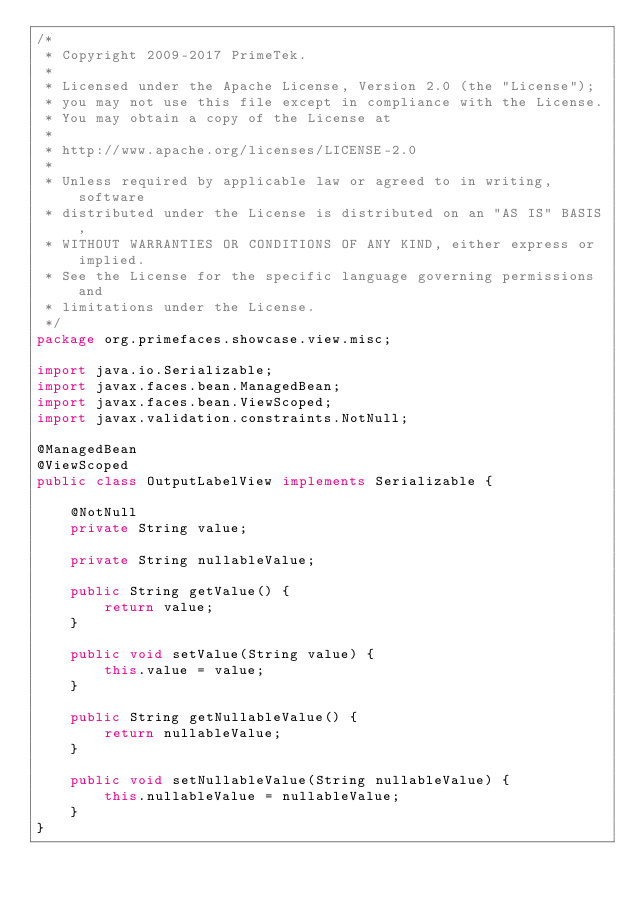<code> <loc_0><loc_0><loc_500><loc_500><_Java_>/*
 * Copyright 2009-2017 PrimeTek.
 *
 * Licensed under the Apache License, Version 2.0 (the "License");
 * you may not use this file except in compliance with the License.
 * You may obtain a copy of the License at
 *
 * http://www.apache.org/licenses/LICENSE-2.0
 *
 * Unless required by applicable law or agreed to in writing, software
 * distributed under the License is distributed on an "AS IS" BASIS,
 * WITHOUT WARRANTIES OR CONDITIONS OF ANY KIND, either express or implied.
 * See the License for the specific language governing permissions and
 * limitations under the License.
 */
package org.primefaces.showcase.view.misc;

import java.io.Serializable;
import javax.faces.bean.ManagedBean;
import javax.faces.bean.ViewScoped;
import javax.validation.constraints.NotNull;

@ManagedBean
@ViewScoped
public class OutputLabelView implements Serializable {

    @NotNull
    private String value;

    private String nullableValue;

    public String getValue() {
        return value;
    }

    public void setValue(String value) {
        this.value = value;
    }

    public String getNullableValue() {
        return nullableValue;
    }

    public void setNullableValue(String nullableValue) {
        this.nullableValue = nullableValue;
    }
}
</code> 